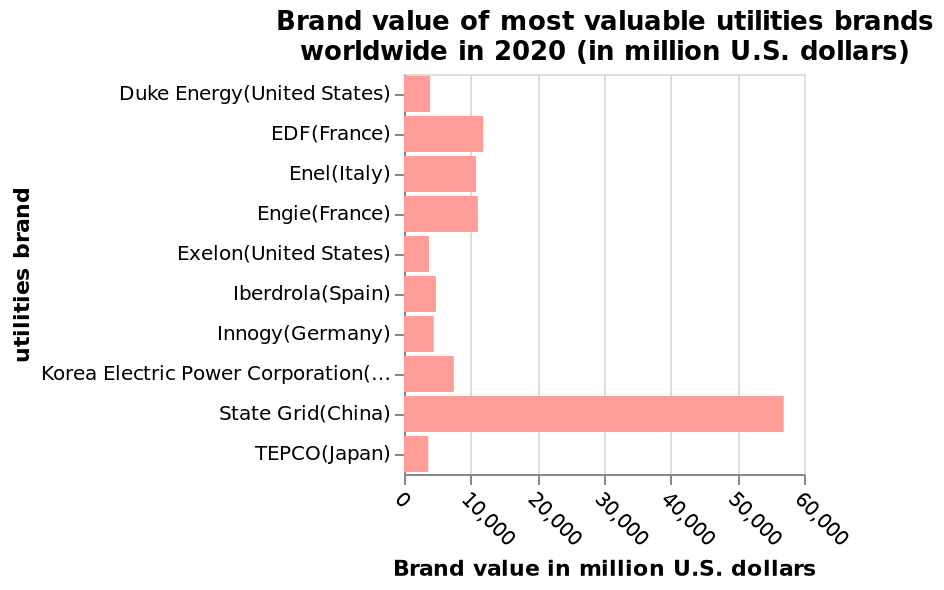<image>
What type of scale is used for the y-axis? The y-axis uses a categorical scale, where the utilities brands are plotted along a categorical scale. please describe the details of the chart This bar plot is called Brand value of most valuable utilities brands worldwide in 2020 (in million U.S. dollars). The y-axis plots utilities brand along categorical scale starting with Duke Energy(United States) and ending with TEPCO(Japan) while the x-axis plots Brand value in million U.S. dollars along linear scale with a minimum of 0 and a maximum of 60,000. What is the name of the bar plot and what does it represent? The bar plot is called "Brand value of most valuable utilities brands worldwide in 2020 (in million U.S. dollars)". It represents the brand value of utility brands worldwide in the year 2020, measured in million U.S. dollars. 